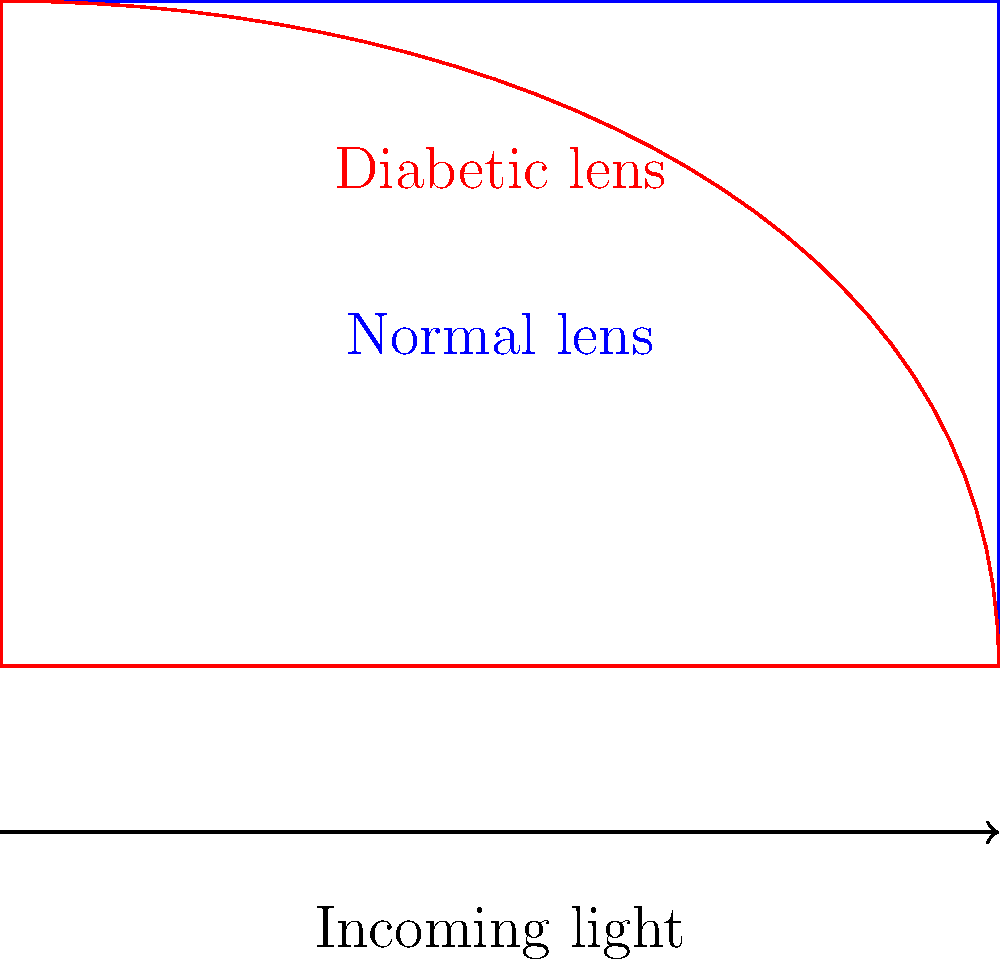In diabetic retinopathy, the lens of the eye can become misshapen due to high blood sugar levels. How does this change in lens shape affect light refraction compared to a normal eye lens, and what implications does this have for vision and the development of specialized corrective lenses? To understand the impact of lens shape on light refraction in diabetic eyes:

1. Normal lens refraction:
   - A healthy eye lens has a symmetrical, biconvex shape.
   - Light rays entering the eye are refracted (bent) consistently across the lens surface.
   - This focuses the light precisely on the retina, resulting in clear vision.

2. Diabetic lens refraction:
   - High blood sugar can cause the lens to swell unevenly, leading to an asymmetrical shape.
   - This irregular shape causes inconsistent refraction of light rays.
   - Some areas of the lens may over-refract light, while others under-refract.

3. Vision implications:
   - The inconsistent refraction results in blurred or distorted vision.
   - Patients may experience difficulty focusing, especially at different distances.
   - This can lead to a condition called diabetic myopia or hyperopia.

4. Corrective lens development:
   - Standard corrective lenses may not adequately address the irregular refraction.
   - Specialized lenses need to be developed to compensate for the specific refractive errors caused by the misshapen diabetic lens.
   - These lenses may include:
     a. Aspherical designs to correct for irregular curvature
     b. Multi-focal elements to address varying refractive powers across the lens
     c. Adaptive materials that can adjust to changes in lens shape over time

5. Importance for pharmaceutical products:
   - Understanding these refractive changes is crucial for developing effective treatments.
   - Medications aimed at stabilizing blood sugar levels can help prevent lens shape changes.
   - Topical treatments that can temporarily normalize lens shape or refractive properties may be beneficial.

The irregular refraction in diabetic eyes necessitates a more complex approach to vision correction, highlighting the need for specialized pharmaceutical and optical solutions.
Answer: Irregular lens shape in diabetic eyes causes inconsistent light refraction, leading to blurred vision and requiring specialized corrective lenses. 